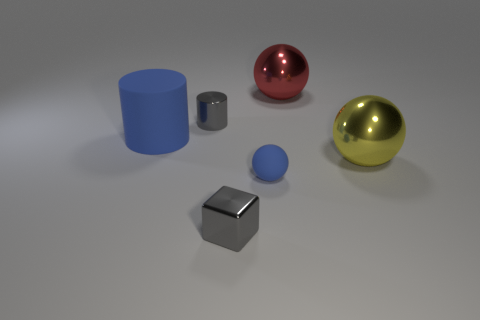What number of objects are yellow spheres or tiny blue matte things that are in front of the red shiny ball?
Make the answer very short. 2. The tiny object in front of the tiny matte object is what color?
Ensure brevity in your answer.  Gray. What is the shape of the yellow shiny thing?
Keep it short and to the point. Sphere. What material is the sphere that is to the left of the ball behind the gray cylinder made of?
Your answer should be very brief. Rubber. How many other things are the same material as the big yellow sphere?
Give a very brief answer. 3. There is a blue thing that is the same size as the yellow shiny thing; what material is it?
Offer a terse response. Rubber. Are there more large yellow spheres that are in front of the gray cube than large shiny spheres that are to the right of the big yellow object?
Make the answer very short. No. Are there any other small rubber things of the same shape as the yellow thing?
Provide a succinct answer. Yes. There is a blue object that is the same size as the shiny block; what is its shape?
Keep it short and to the point. Sphere. There is a small gray thing in front of the gray shiny cylinder; what is its shape?
Your answer should be very brief. Cube. 